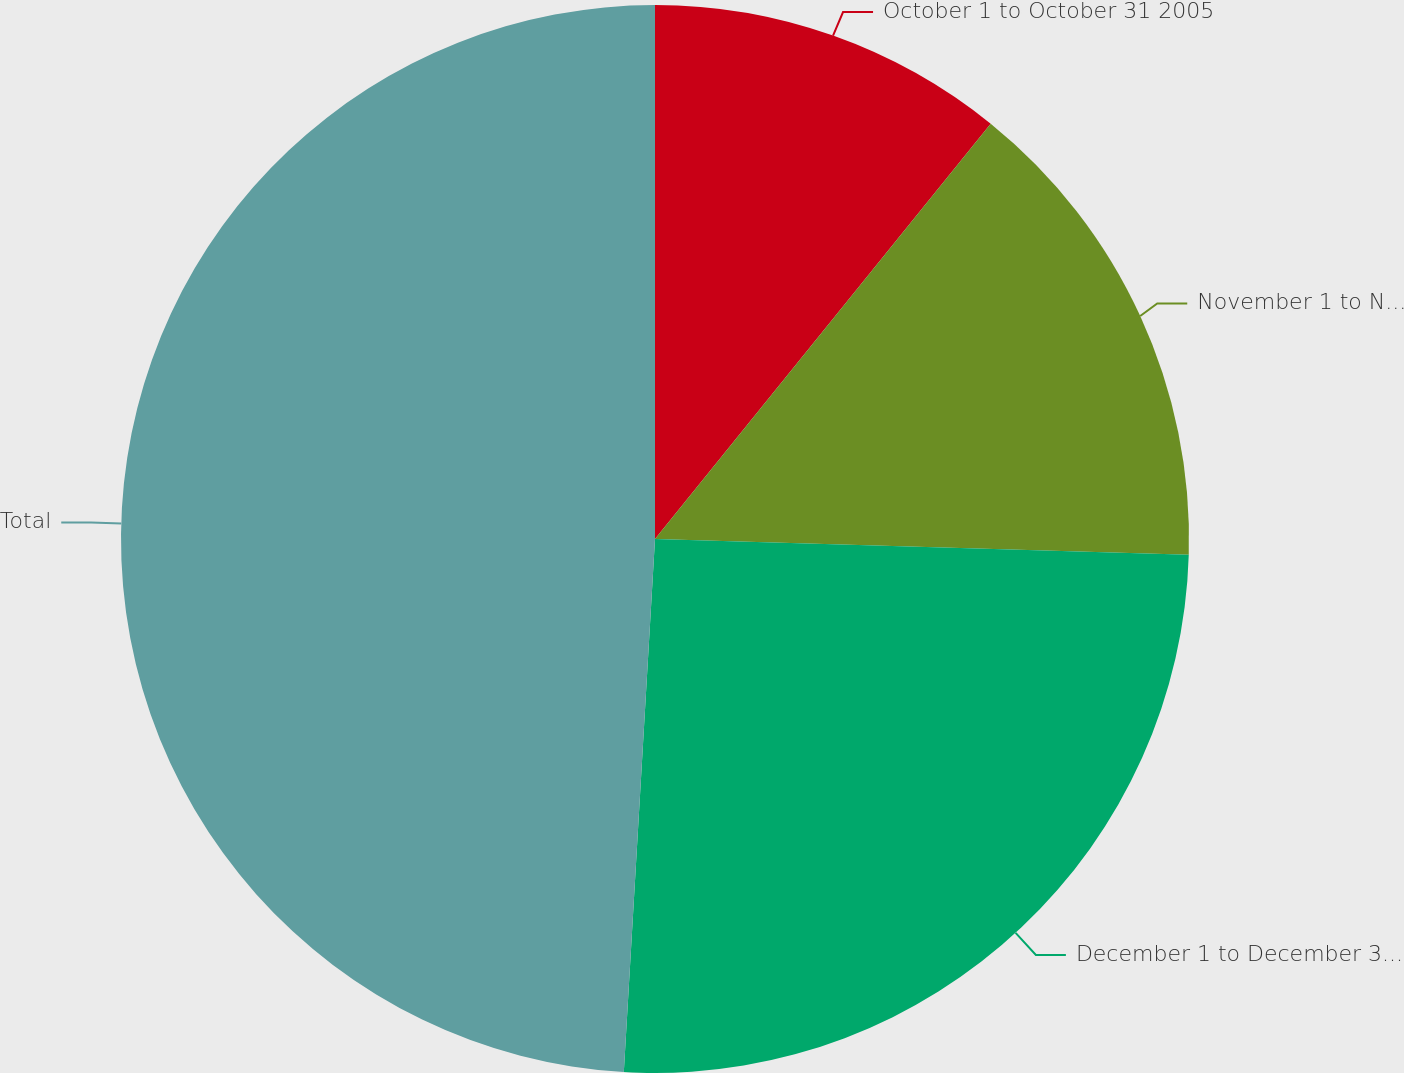<chart> <loc_0><loc_0><loc_500><loc_500><pie_chart><fcel>October 1 to October 31 2005<fcel>November 1 to November 30 2005<fcel>December 1 to December 31 2005<fcel>Total<nl><fcel>10.82%<fcel>14.65%<fcel>25.46%<fcel>49.07%<nl></chart> 